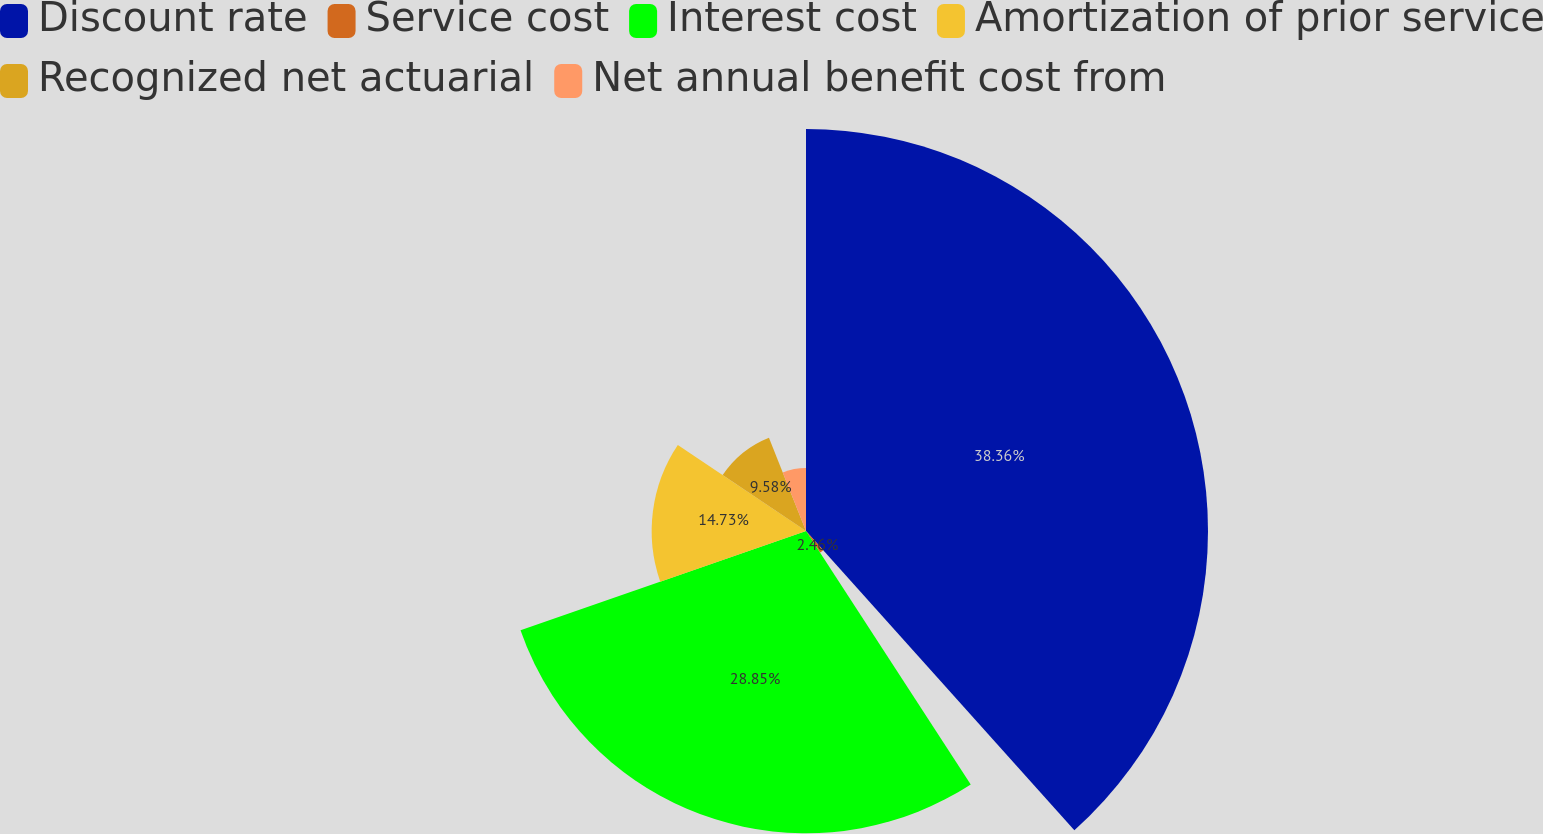Convert chart to OTSL. <chart><loc_0><loc_0><loc_500><loc_500><pie_chart><fcel>Discount rate<fcel>Service cost<fcel>Interest cost<fcel>Amortization of prior service<fcel>Recognized net actuarial<fcel>Net annual benefit cost from<nl><fcel>38.37%<fcel>2.46%<fcel>28.85%<fcel>14.73%<fcel>9.58%<fcel>6.02%<nl></chart> 